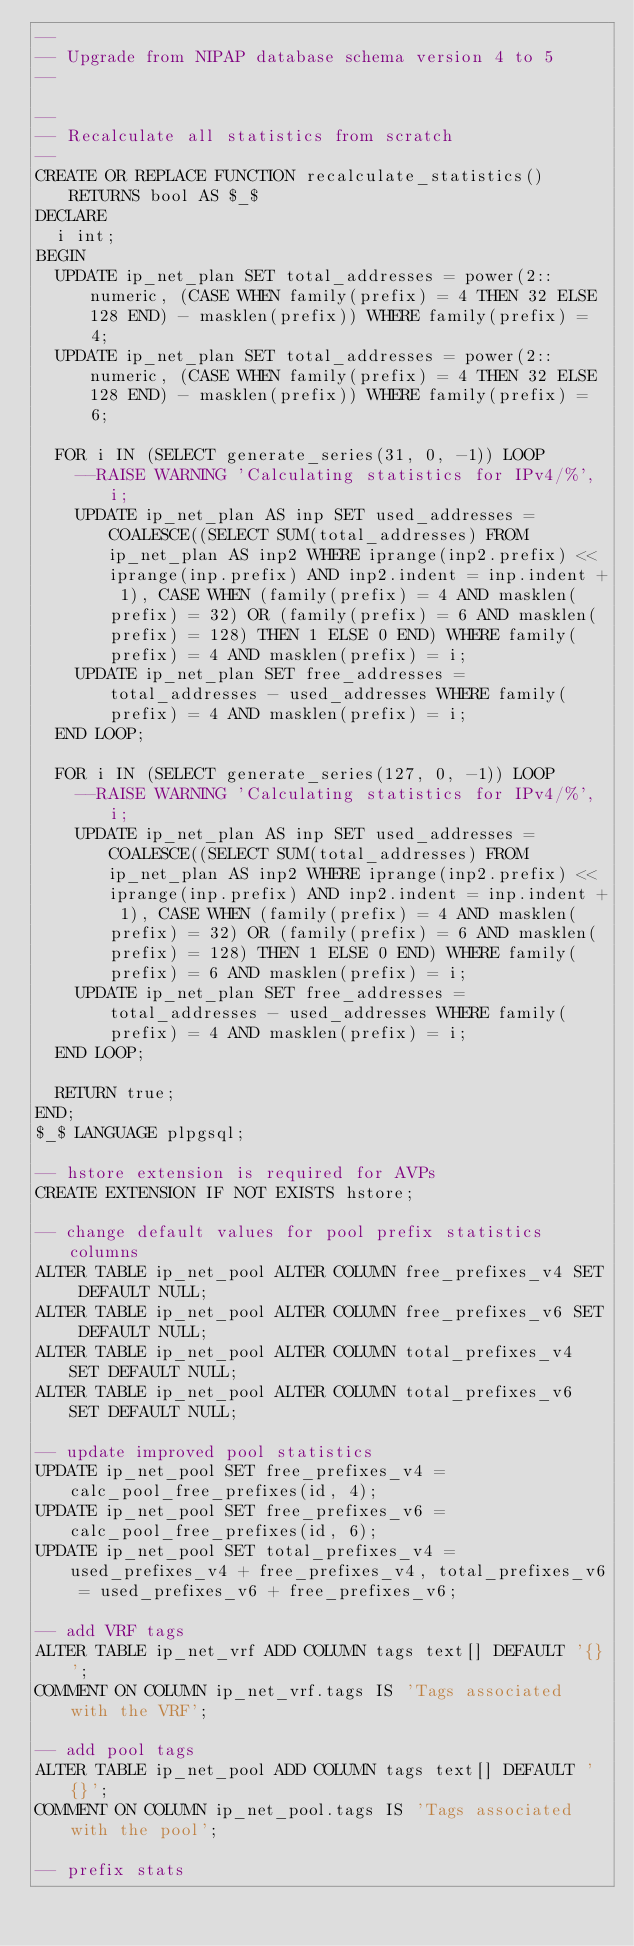<code> <loc_0><loc_0><loc_500><loc_500><_SQL_>--
-- Upgrade from NIPAP database schema version 4 to 5
--

--
-- Recalculate all statistics from scratch
--
CREATE OR REPLACE FUNCTION recalculate_statistics() RETURNS bool AS $_$
DECLARE
	i int;
BEGIN
	UPDATE ip_net_plan SET total_addresses = power(2::numeric, (CASE WHEN family(prefix) = 4 THEN 32 ELSE 128 END) - masklen(prefix)) WHERE family(prefix) = 4;
	UPDATE ip_net_plan SET total_addresses = power(2::numeric, (CASE WHEN family(prefix) = 4 THEN 32 ELSE 128 END) - masklen(prefix)) WHERE family(prefix) = 6;

	FOR i IN (SELECT generate_series(31, 0, -1)) LOOP
		--RAISE WARNING 'Calculating statistics for IPv4/%', i;
		UPDATE ip_net_plan AS inp SET used_addresses = COALESCE((SELECT SUM(total_addresses) FROM ip_net_plan AS inp2 WHERE iprange(inp2.prefix) << iprange(inp.prefix) AND inp2.indent = inp.indent + 1), CASE WHEN (family(prefix) = 4 AND masklen(prefix) = 32) OR (family(prefix) = 6 AND masklen(prefix) = 128) THEN 1 ELSE 0 END) WHERE family(prefix) = 4 AND masklen(prefix) = i;
		UPDATE ip_net_plan SET free_addresses = total_addresses - used_addresses WHERE family(prefix) = 4 AND masklen(prefix) = i;
	END LOOP;

	FOR i IN (SELECT generate_series(127, 0, -1)) LOOP
		--RAISE WARNING 'Calculating statistics for IPv4/%', i;
		UPDATE ip_net_plan AS inp SET used_addresses = COALESCE((SELECT SUM(total_addresses) FROM ip_net_plan AS inp2 WHERE iprange(inp2.prefix) << iprange(inp.prefix) AND inp2.indent = inp.indent + 1), CASE WHEN (family(prefix) = 4 AND masklen(prefix) = 32) OR (family(prefix) = 6 AND masklen(prefix) = 128) THEN 1 ELSE 0 END) WHERE family(prefix) = 6 AND masklen(prefix) = i;
		UPDATE ip_net_plan SET free_addresses = total_addresses - used_addresses WHERE family(prefix) = 4 AND masklen(prefix) = i;
	END LOOP;

	RETURN true;
END;
$_$ LANGUAGE plpgsql;

-- hstore extension is required for AVPs
CREATE EXTENSION IF NOT EXISTS hstore;

-- change default values for pool prefix statistics columns
ALTER TABLE ip_net_pool ALTER COLUMN free_prefixes_v4 SET DEFAULT NULL;
ALTER TABLE ip_net_pool ALTER COLUMN free_prefixes_v6 SET DEFAULT NULL;
ALTER TABLE ip_net_pool ALTER COLUMN total_prefixes_v4 SET DEFAULT NULL;
ALTER TABLE ip_net_pool ALTER COLUMN total_prefixes_v6 SET DEFAULT NULL;

-- update improved pool statistics
UPDATE ip_net_pool SET free_prefixes_v4 = calc_pool_free_prefixes(id, 4);
UPDATE ip_net_pool SET free_prefixes_v6 = calc_pool_free_prefixes(id, 6);
UPDATE ip_net_pool SET total_prefixes_v4 = used_prefixes_v4 + free_prefixes_v4, total_prefixes_v6 = used_prefixes_v6 + free_prefixes_v6;

-- add VRF tags
ALTER TABLE ip_net_vrf ADD COLUMN tags text[] DEFAULT '{}';
COMMENT ON COLUMN ip_net_vrf.tags IS 'Tags associated with the VRF';

-- add pool tags
ALTER TABLE ip_net_pool ADD COLUMN tags text[] DEFAULT '{}';
COMMENT ON COLUMN ip_net_pool.tags IS 'Tags associated with the pool';

-- prefix stats</code> 